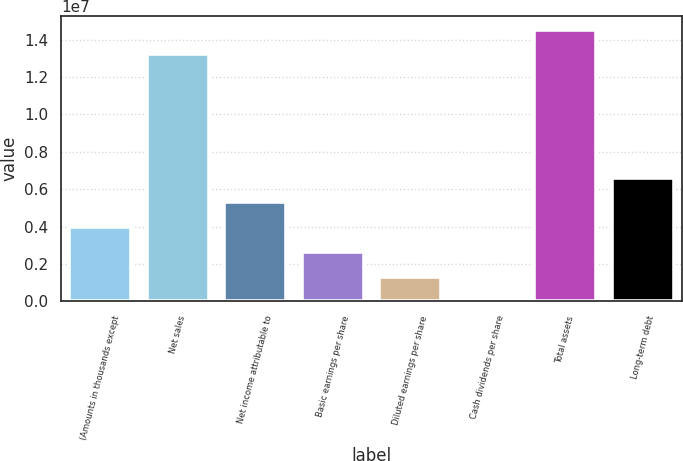<chart> <loc_0><loc_0><loc_500><loc_500><bar_chart><fcel>(Amounts in thousands except<fcel>Net sales<fcel>Net income attributable to<fcel>Basic earnings per share<fcel>Diluted earnings per share<fcel>Cash dividends per share<fcel>Total assets<fcel>Long-term debt<nl><fcel>3.97497e+06<fcel>1.3216e+07<fcel>5.29996e+06<fcel>2.64998e+06<fcel>1.32499e+06<fcel>1.86<fcel>1.4541e+07<fcel>6.62495e+06<nl></chart> 